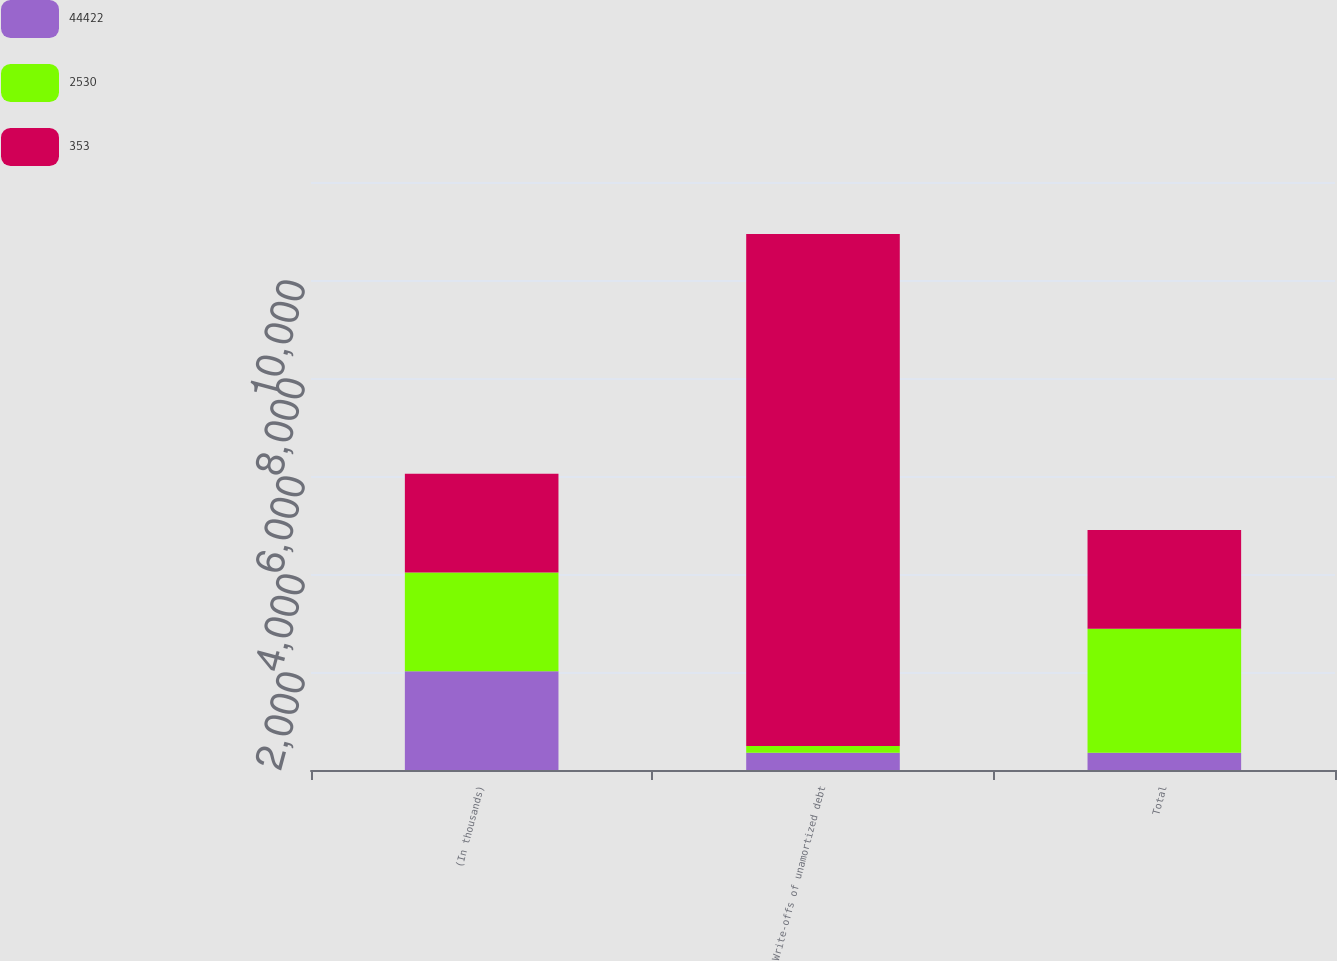Convert chart to OTSL. <chart><loc_0><loc_0><loc_500><loc_500><stacked_bar_chart><ecel><fcel>(In thousands)<fcel>Write-offs of unamortized debt<fcel>Total<nl><fcel>44422<fcel>2016<fcel>353<fcel>353<nl><fcel>2530<fcel>2015<fcel>135<fcel>2530<nl><fcel>353<fcel>2014<fcel>10451<fcel>2014.5<nl></chart> 